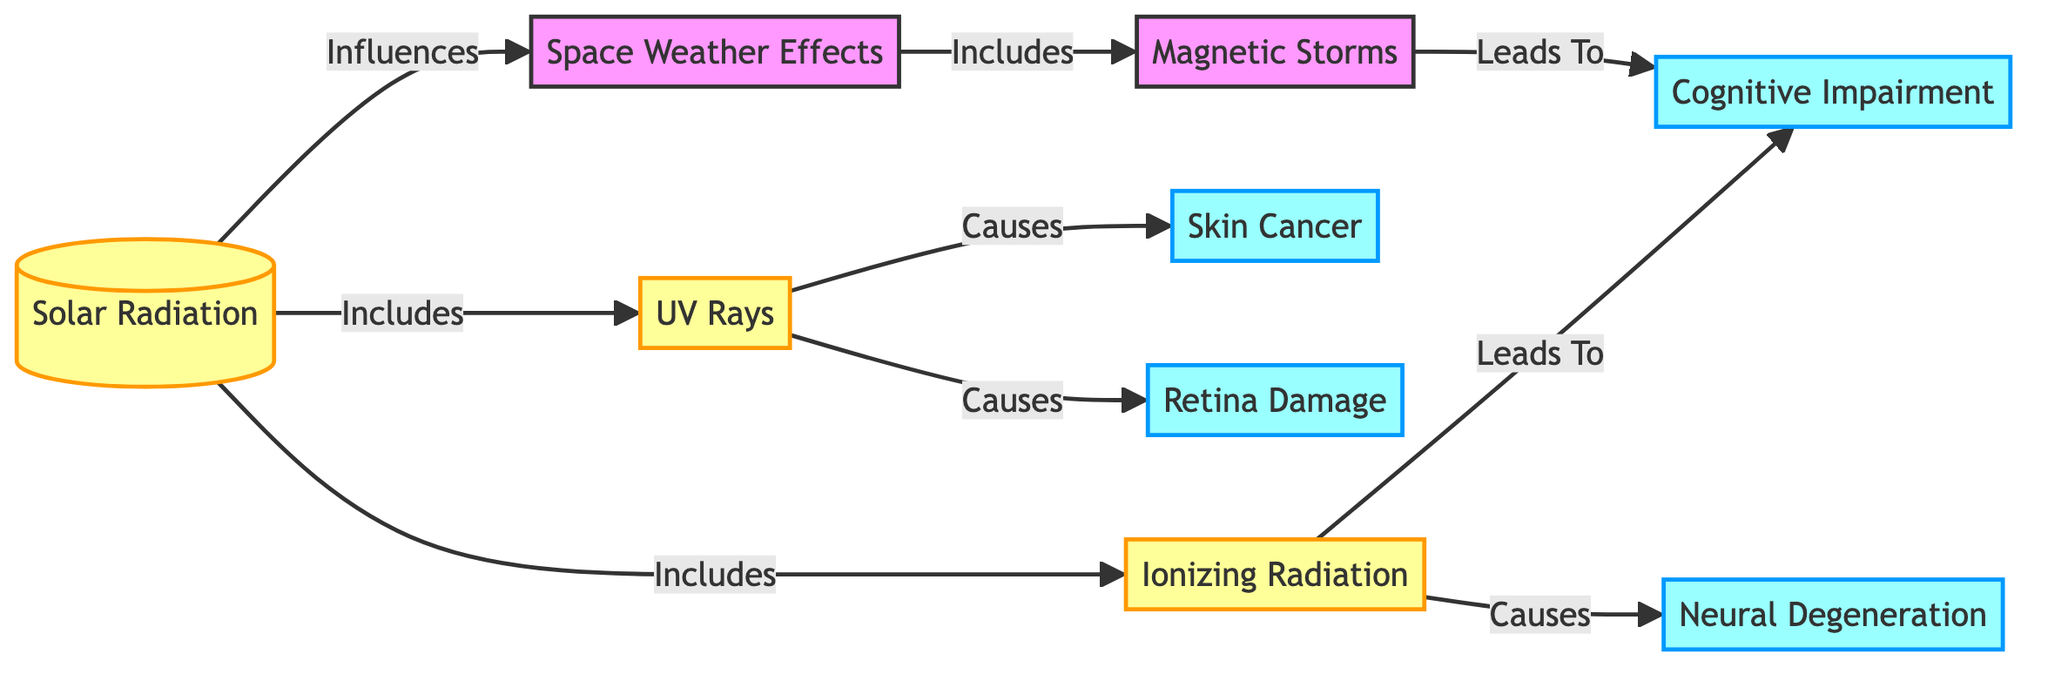What's the main topic of the diagram? The diagram centers on "Solar Radiation" as it is the top node, signifying that the information flows down from this key topic.
Answer: Solar Radiation How many types of radiation are included under Solar Radiation? The diagram shows two types of radiation directly linked to Solar Radiation: "UV Rays" and "Ionizing Radiation". Counting these gives a total of two.
Answer: 2 What effect does UV Rays cause according to the diagram? The diagram specifies two effects resulting from UV Rays: "Skin Cancer" and "Retina Damage".
Answer: Skin Cancer, Retina Damage What neurological issue is linked to Ionizing Radiation? The diagram indicates that "Cognitive Impairment" is a consequence of Ionizing Radiation, connecting two nodes in the relationship.
Answer: Cognitive Impairment Which external factor influences Solar Radiation? The diagram specifies that "Space Weather Effects" are influenced by Solar Radiation, showing a directional relationship from Solar Radiation to this effect.
Answer: Space Weather Effects What is the consequence of Magnetic Storms as shown in the diagram? The flow of the diagram indicates that "Cognitive Impairment" is a result of "Magnetic Storms", reflecting that cognitive issues can arise from this specific input.
Answer: Cognitive Impairment How many overall effects are mentioned in the diagram? The diagram lists a total of four effects: "Skin Cancer," "Retina Damage," "Cognitive Impairment," and "Neural Degeneration." Counting these results in four distinct effects.
Answer: 4 What relationship does "Ionizing Radiation" have with "Neural Degeneration"? The diagram shows that Ionizing Radiation "Causes" Neural Degeneration, indicating a direct causative link between these two nodes.
Answer: Causes What is the effect of Space Weather on cognitive functionality according to the diagram? The diagram illustrates that "Magnetic Storms," categorized under Space Weather Effects, can lead to "Cognitive Impairment," establishing a connection to cognitive functionality.
Answer: Cognitive Impairment 